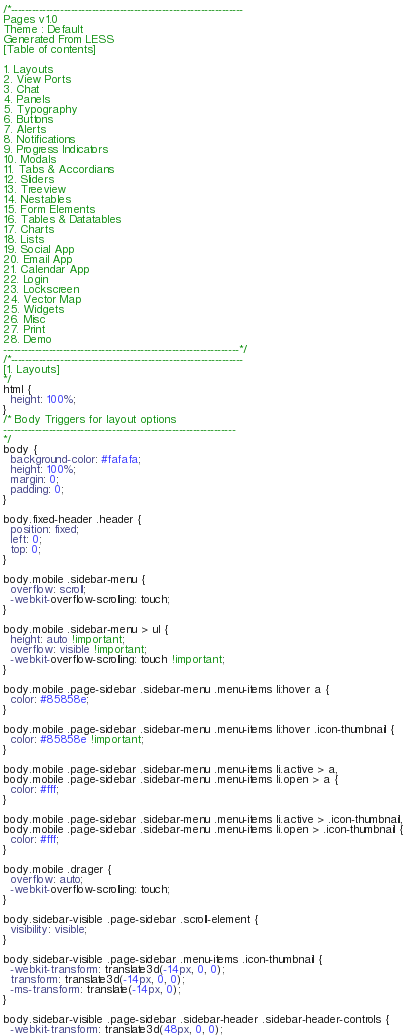<code> <loc_0><loc_0><loc_500><loc_500><_CSS_>/*------------------------------------------------------------------
Pages v1.0
Theme : Default
Generated From LESS
[Table of contents]

1. Layouts
2. View Ports
3. Chat
4. Panels
5. Typography
6. Buttons
7. Alerts
8. Notifications
9. Progress Indicators
10. Modals
11. Tabs & Accordians
12. Sliders
13. Treeview
14. Nestables
15. Form Elements
16. Tables & Datatables
17. Charts
18. Lists
19. Social App
20. Email App
21. Calendar App
22. Login
23. Lockscreen
24. Vector Map
25. Widgets
26. Misc
27. Print
28. Demo
-------------------------------------------------------------------*/
/*------------------------------------------------------------------
[1. Layouts]
*/
html {
  height: 100%;
}
/* Body Triggers for layout options 
------------------------------------------------------------------
*/
body {
  background-color: #fafafa;
  height: 100%;
  margin: 0;
  padding: 0;
}

body.fixed-header .header {
  position: fixed;
  left: 0;
  top: 0;
}

body.mobile .sidebar-menu {
  overflow: scroll;
  -webkit-overflow-scrolling: touch;
}

body.mobile .sidebar-menu > ul {
  height: auto !important;
  overflow: visible !important;
  -webkit-overflow-scrolling: touch !important;
}

body.mobile .page-sidebar .sidebar-menu .menu-items li:hover a {
  color: #85858e;
}

body.mobile .page-sidebar .sidebar-menu .menu-items li:hover .icon-thumbnail {
  color: #85858e !important;
}

body.mobile .page-sidebar .sidebar-menu .menu-items li.active > a,
body.mobile .page-sidebar .sidebar-menu .menu-items li.open > a {
  color: #fff;
}

body.mobile .page-sidebar .sidebar-menu .menu-items li.active > .icon-thumbnail,
body.mobile .page-sidebar .sidebar-menu .menu-items li.open > .icon-thumbnail {
  color: #fff;
}

body.mobile .drager {
  overflow: auto;
  -webkit-overflow-scrolling: touch;
}

body.sidebar-visible .page-sidebar .scroll-element {
  visibility: visible;
}

body.sidebar-visible .page-sidebar .menu-items .icon-thumbnail {
  -webkit-transform: translate3d(-14px, 0, 0);
  transform: translate3d(-14px, 0, 0);
  -ms-transform: translate(-14px, 0);
}

body.sidebar-visible .page-sidebar .sidebar-header .sidebar-header-controls {
  -webkit-transform: translate3d(48px, 0, 0);</code> 